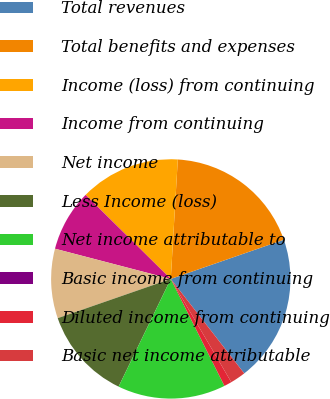<chart> <loc_0><loc_0><loc_500><loc_500><pie_chart><fcel>Total revenues<fcel>Total benefits and expenses<fcel>Income (loss) from continuing<fcel>Income from continuing<fcel>Net income<fcel>Less Income (loss)<fcel>Net income attributable to<fcel>Basic income from continuing<fcel>Diluted income from continuing<fcel>Basic net income attributable<nl><fcel>19.79%<fcel>18.75%<fcel>13.54%<fcel>8.33%<fcel>9.38%<fcel>12.5%<fcel>14.58%<fcel>0.0%<fcel>1.04%<fcel>2.08%<nl></chart> 